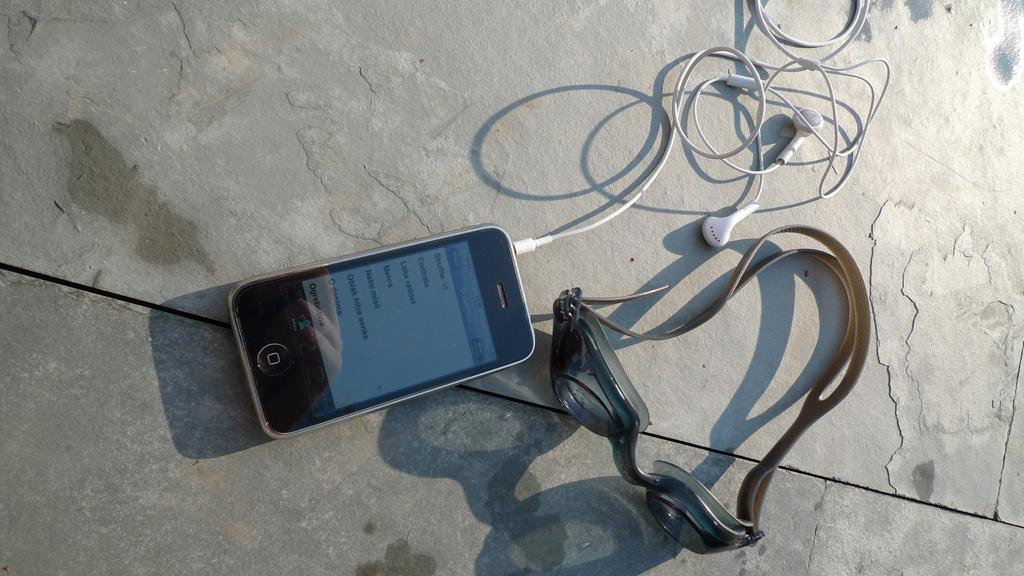<image>
Summarize the visual content of the image. The first selection on the smartphone is to shuffle songs. 